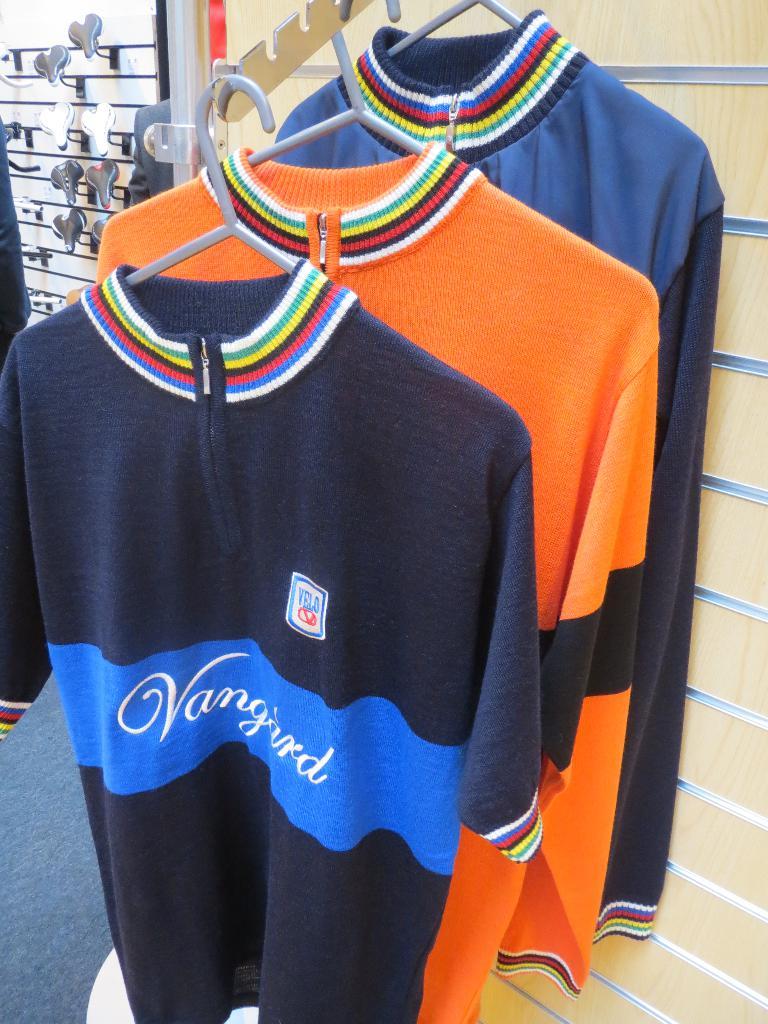What is the shirt brand?
Offer a terse response. Vanguard. What does that sticker above the name say?
Provide a succinct answer. Velo. 